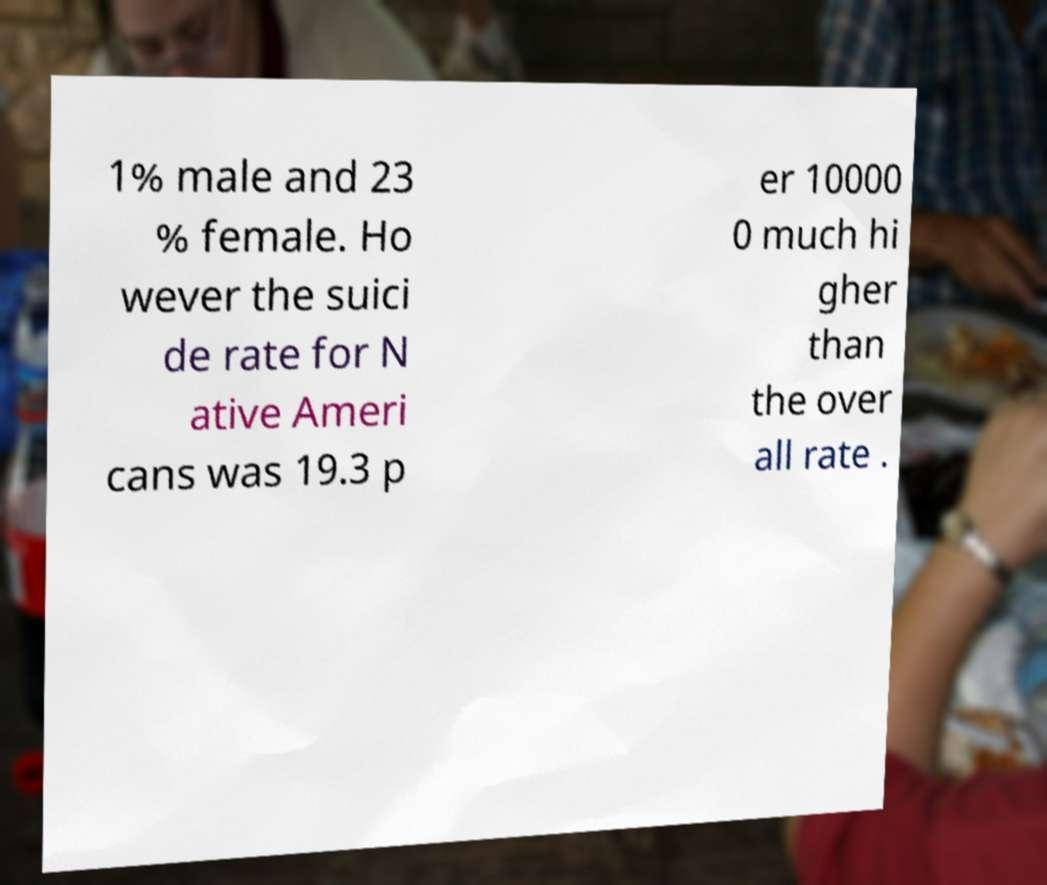Please identify and transcribe the text found in this image. 1% male and 23 % female. Ho wever the suici de rate for N ative Ameri cans was 19.3 p er 10000 0 much hi gher than the over all rate . 